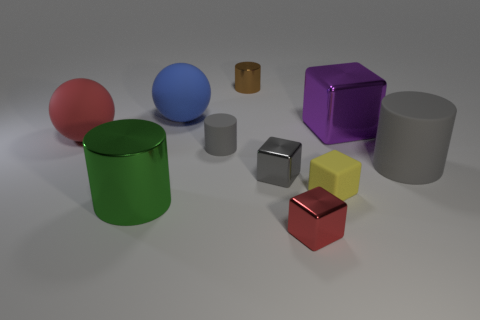There is a shiny cylinder that is behind the purple metal object; does it have the same size as the yellow matte object? The shiny cylinder positioned behind the purple object appears to be of a smaller size compared to the yellow cube when we consider their respective heights and diameters. The yellow cube presents with a larger surface area visible from this angle, which generally indicates a greater volume. 